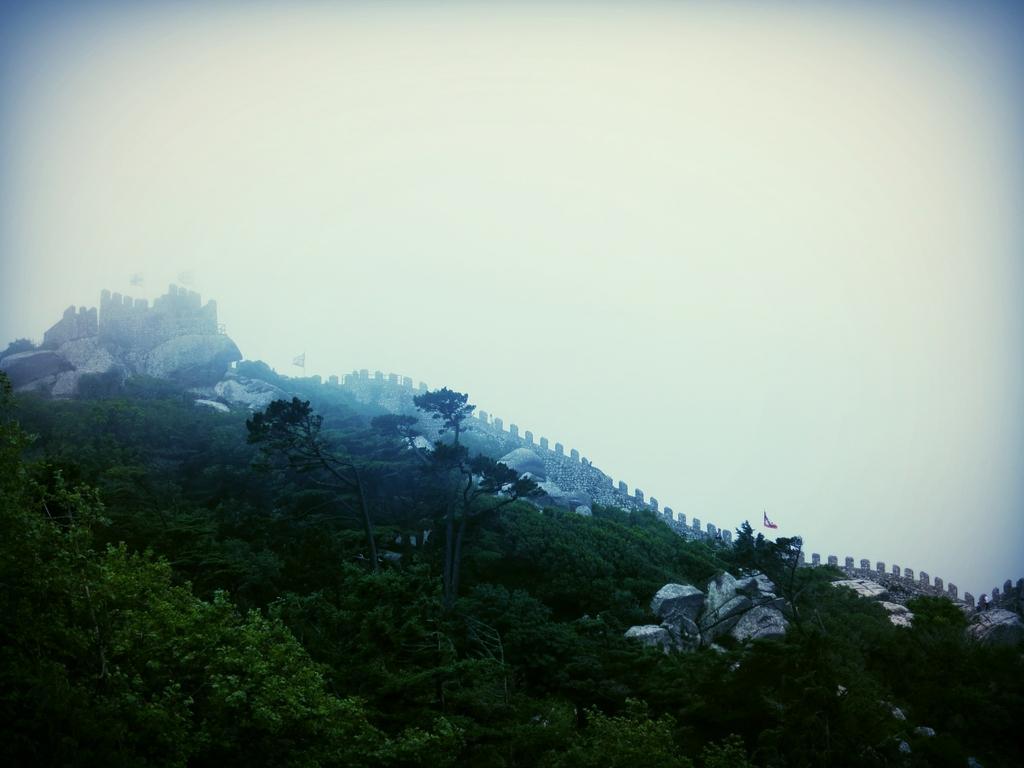Can you describe this image briefly? In this image at the bottom, there are trees, stones. In the middle there are stones, for, wall, flag. At the top there is sky. 